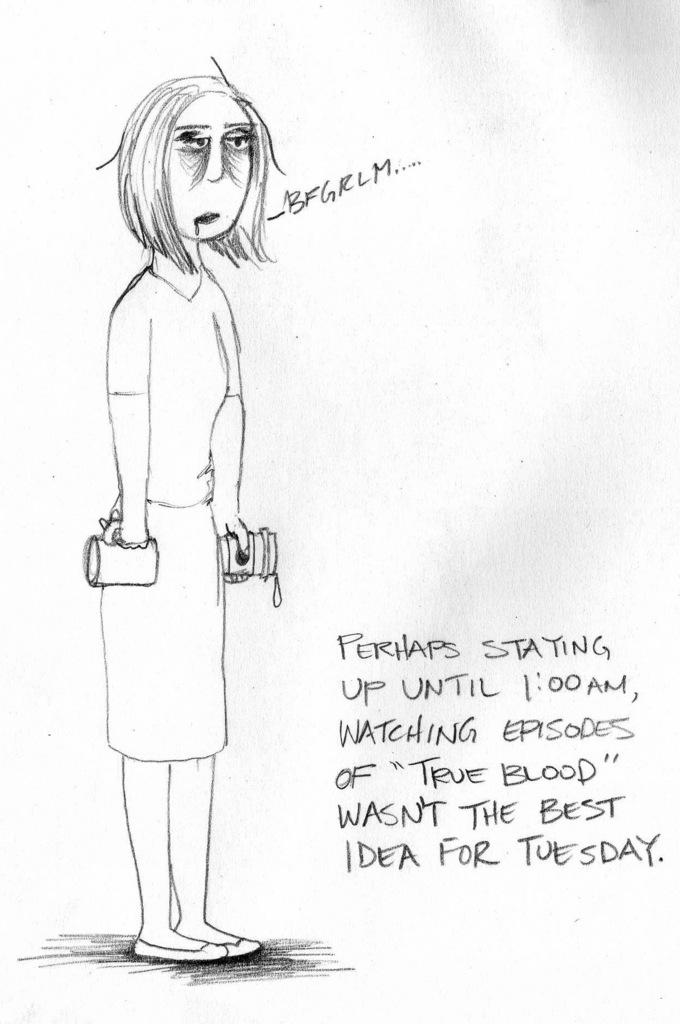What is the main subject of the image? There is a depiction of a woman in the image. Are there any words or text in the image? Yes, there is writing in the image. What color is the background of the image? The background of the image is white. What type of apparel is the governor wearing in the image? There is no governor or apparel present in the image; it features a depiction of a woman and writing on a white background. 